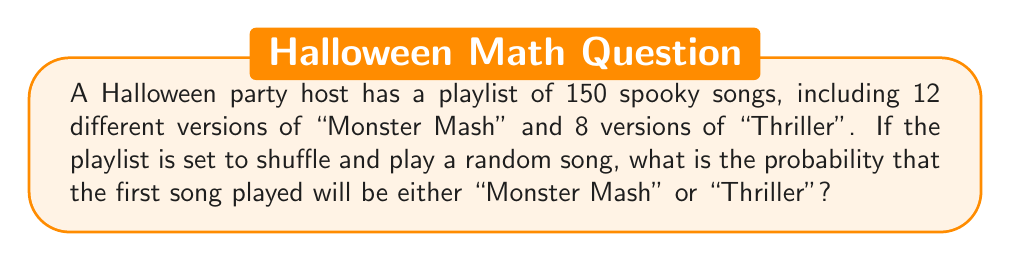Help me with this question. Let's approach this step-by-step:

1) First, we need to identify the total number of favorable outcomes:
   - Number of "Monster Mash" versions: 12
   - Number of "Thriller" versions: 8
   - Total favorable outcomes: $12 + 8 = 20$

2) We know the total number of songs in the playlist: 150

3) The probability of an event is calculated by dividing the number of favorable outcomes by the total number of possible outcomes:

   $$P(\text{event}) = \frac{\text{favorable outcomes}}{\text{total outcomes}}$$

4) In this case:
   
   $$P(\text{"Monster Mash" or "Thriller"}) = \frac{20}{150}$$

5) We can simplify this fraction:
   
   $$\frac{20}{150} = \frac{2}{15} = 0.1333...$$

6) To express this as a percentage, we multiply by 100:
   
   $$0.1333... \times 100 = 13.33...\%$$

Therefore, the probability of the first song being either "Monster Mash" or "Thriller" is approximately 13.33% or $\frac{2}{15}$.
Answer: $\frac{2}{15}$ or approximately 13.33% 